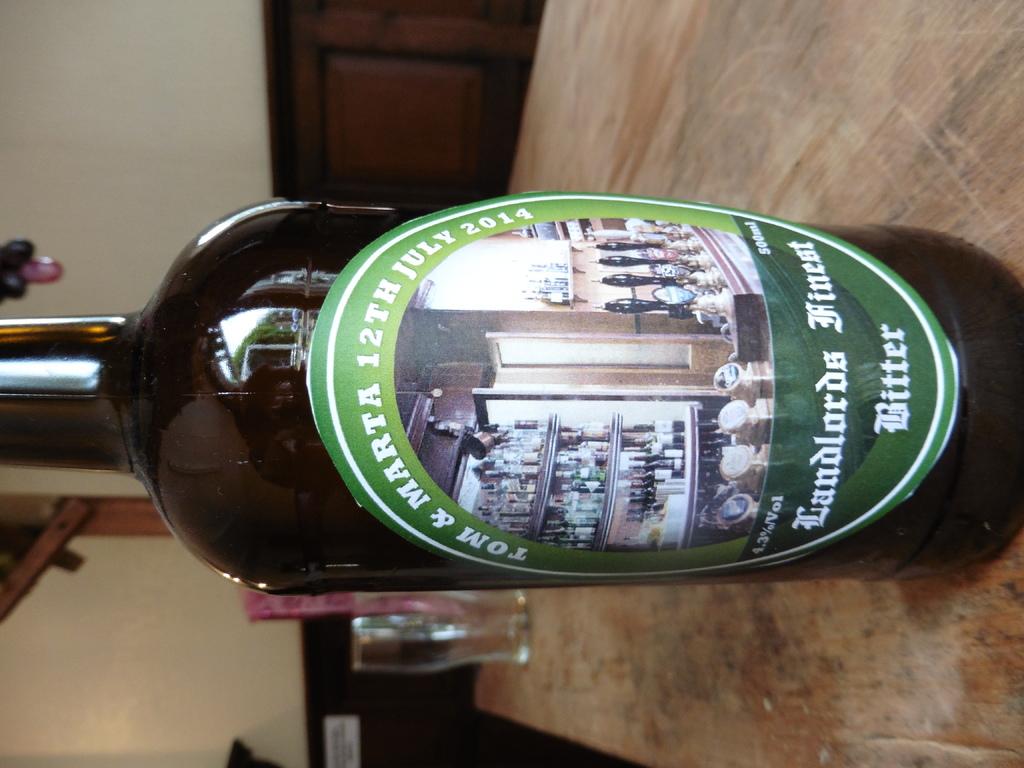What percentage alcohol is this beverage?
Offer a terse response. 4.3. What brand of beer?
Provide a short and direct response. Landlords finest bitter. 